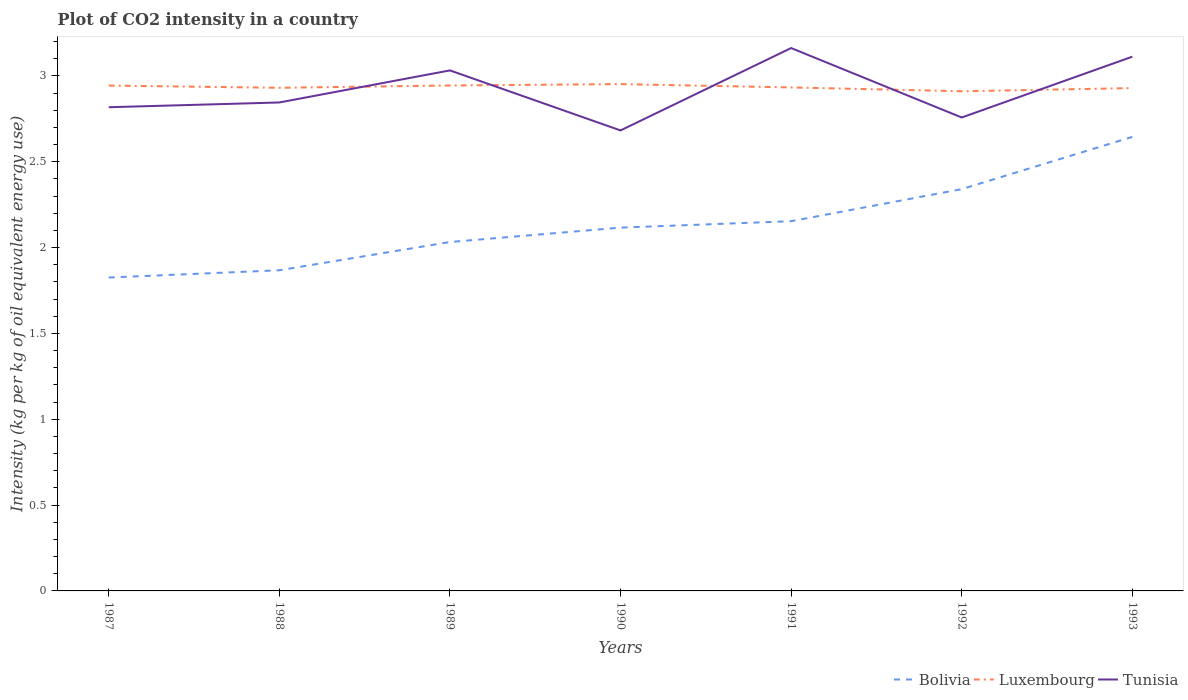Across all years, what is the maximum CO2 intensity in in Bolivia?
Give a very brief answer. 1.83. In which year was the CO2 intensity in in Tunisia maximum?
Keep it short and to the point. 1990. What is the total CO2 intensity in in Tunisia in the graph?
Provide a succinct answer. 0.35. What is the difference between the highest and the second highest CO2 intensity in in Bolivia?
Provide a short and direct response. 0.82. What is the difference between the highest and the lowest CO2 intensity in in Bolivia?
Provide a short and direct response. 3. Is the CO2 intensity in in Tunisia strictly greater than the CO2 intensity in in Luxembourg over the years?
Provide a succinct answer. No. What is the difference between two consecutive major ticks on the Y-axis?
Offer a terse response. 0.5. Are the values on the major ticks of Y-axis written in scientific E-notation?
Provide a succinct answer. No. Does the graph contain any zero values?
Provide a succinct answer. No. What is the title of the graph?
Your response must be concise. Plot of CO2 intensity in a country. Does "Ethiopia" appear as one of the legend labels in the graph?
Keep it short and to the point. No. What is the label or title of the X-axis?
Give a very brief answer. Years. What is the label or title of the Y-axis?
Your answer should be compact. Intensity (kg per kg of oil equivalent energy use). What is the Intensity (kg per kg of oil equivalent energy use) in Bolivia in 1987?
Ensure brevity in your answer.  1.83. What is the Intensity (kg per kg of oil equivalent energy use) of Luxembourg in 1987?
Your answer should be compact. 2.94. What is the Intensity (kg per kg of oil equivalent energy use) of Tunisia in 1987?
Offer a terse response. 2.82. What is the Intensity (kg per kg of oil equivalent energy use) of Bolivia in 1988?
Your answer should be very brief. 1.87. What is the Intensity (kg per kg of oil equivalent energy use) of Luxembourg in 1988?
Offer a very short reply. 2.93. What is the Intensity (kg per kg of oil equivalent energy use) in Tunisia in 1988?
Give a very brief answer. 2.85. What is the Intensity (kg per kg of oil equivalent energy use) of Bolivia in 1989?
Make the answer very short. 2.03. What is the Intensity (kg per kg of oil equivalent energy use) of Luxembourg in 1989?
Provide a succinct answer. 2.94. What is the Intensity (kg per kg of oil equivalent energy use) in Tunisia in 1989?
Your response must be concise. 3.03. What is the Intensity (kg per kg of oil equivalent energy use) in Bolivia in 1990?
Provide a short and direct response. 2.12. What is the Intensity (kg per kg of oil equivalent energy use) of Luxembourg in 1990?
Offer a terse response. 2.95. What is the Intensity (kg per kg of oil equivalent energy use) of Tunisia in 1990?
Provide a succinct answer. 2.68. What is the Intensity (kg per kg of oil equivalent energy use) in Bolivia in 1991?
Make the answer very short. 2.15. What is the Intensity (kg per kg of oil equivalent energy use) of Luxembourg in 1991?
Offer a terse response. 2.93. What is the Intensity (kg per kg of oil equivalent energy use) in Tunisia in 1991?
Your answer should be very brief. 3.16. What is the Intensity (kg per kg of oil equivalent energy use) of Bolivia in 1992?
Keep it short and to the point. 2.34. What is the Intensity (kg per kg of oil equivalent energy use) of Luxembourg in 1992?
Your response must be concise. 2.91. What is the Intensity (kg per kg of oil equivalent energy use) in Tunisia in 1992?
Your answer should be compact. 2.76. What is the Intensity (kg per kg of oil equivalent energy use) of Bolivia in 1993?
Ensure brevity in your answer.  2.64. What is the Intensity (kg per kg of oil equivalent energy use) of Luxembourg in 1993?
Provide a succinct answer. 2.93. What is the Intensity (kg per kg of oil equivalent energy use) in Tunisia in 1993?
Keep it short and to the point. 3.11. Across all years, what is the maximum Intensity (kg per kg of oil equivalent energy use) in Bolivia?
Your response must be concise. 2.64. Across all years, what is the maximum Intensity (kg per kg of oil equivalent energy use) of Luxembourg?
Make the answer very short. 2.95. Across all years, what is the maximum Intensity (kg per kg of oil equivalent energy use) in Tunisia?
Your answer should be compact. 3.16. Across all years, what is the minimum Intensity (kg per kg of oil equivalent energy use) in Bolivia?
Offer a terse response. 1.83. Across all years, what is the minimum Intensity (kg per kg of oil equivalent energy use) in Luxembourg?
Ensure brevity in your answer.  2.91. Across all years, what is the minimum Intensity (kg per kg of oil equivalent energy use) of Tunisia?
Give a very brief answer. 2.68. What is the total Intensity (kg per kg of oil equivalent energy use) of Bolivia in the graph?
Give a very brief answer. 14.98. What is the total Intensity (kg per kg of oil equivalent energy use) of Luxembourg in the graph?
Your answer should be compact. 20.54. What is the total Intensity (kg per kg of oil equivalent energy use) of Tunisia in the graph?
Make the answer very short. 20.41. What is the difference between the Intensity (kg per kg of oil equivalent energy use) in Bolivia in 1987 and that in 1988?
Provide a succinct answer. -0.04. What is the difference between the Intensity (kg per kg of oil equivalent energy use) in Luxembourg in 1987 and that in 1988?
Keep it short and to the point. 0.01. What is the difference between the Intensity (kg per kg of oil equivalent energy use) of Tunisia in 1987 and that in 1988?
Keep it short and to the point. -0.03. What is the difference between the Intensity (kg per kg of oil equivalent energy use) in Bolivia in 1987 and that in 1989?
Offer a terse response. -0.21. What is the difference between the Intensity (kg per kg of oil equivalent energy use) in Luxembourg in 1987 and that in 1989?
Keep it short and to the point. -0. What is the difference between the Intensity (kg per kg of oil equivalent energy use) in Tunisia in 1987 and that in 1989?
Provide a short and direct response. -0.21. What is the difference between the Intensity (kg per kg of oil equivalent energy use) of Bolivia in 1987 and that in 1990?
Make the answer very short. -0.29. What is the difference between the Intensity (kg per kg of oil equivalent energy use) of Luxembourg in 1987 and that in 1990?
Your response must be concise. -0.01. What is the difference between the Intensity (kg per kg of oil equivalent energy use) in Tunisia in 1987 and that in 1990?
Ensure brevity in your answer.  0.14. What is the difference between the Intensity (kg per kg of oil equivalent energy use) of Bolivia in 1987 and that in 1991?
Provide a short and direct response. -0.33. What is the difference between the Intensity (kg per kg of oil equivalent energy use) in Luxembourg in 1987 and that in 1991?
Your answer should be compact. 0.01. What is the difference between the Intensity (kg per kg of oil equivalent energy use) of Tunisia in 1987 and that in 1991?
Your answer should be very brief. -0.34. What is the difference between the Intensity (kg per kg of oil equivalent energy use) of Bolivia in 1987 and that in 1992?
Offer a very short reply. -0.52. What is the difference between the Intensity (kg per kg of oil equivalent energy use) of Luxembourg in 1987 and that in 1992?
Offer a terse response. 0.03. What is the difference between the Intensity (kg per kg of oil equivalent energy use) of Tunisia in 1987 and that in 1992?
Offer a very short reply. 0.06. What is the difference between the Intensity (kg per kg of oil equivalent energy use) in Bolivia in 1987 and that in 1993?
Your answer should be very brief. -0.82. What is the difference between the Intensity (kg per kg of oil equivalent energy use) of Luxembourg in 1987 and that in 1993?
Provide a succinct answer. 0.01. What is the difference between the Intensity (kg per kg of oil equivalent energy use) in Tunisia in 1987 and that in 1993?
Provide a succinct answer. -0.29. What is the difference between the Intensity (kg per kg of oil equivalent energy use) in Bolivia in 1988 and that in 1989?
Keep it short and to the point. -0.16. What is the difference between the Intensity (kg per kg of oil equivalent energy use) of Luxembourg in 1988 and that in 1989?
Keep it short and to the point. -0.01. What is the difference between the Intensity (kg per kg of oil equivalent energy use) of Tunisia in 1988 and that in 1989?
Your answer should be very brief. -0.19. What is the difference between the Intensity (kg per kg of oil equivalent energy use) of Bolivia in 1988 and that in 1990?
Provide a short and direct response. -0.25. What is the difference between the Intensity (kg per kg of oil equivalent energy use) of Luxembourg in 1988 and that in 1990?
Make the answer very short. -0.02. What is the difference between the Intensity (kg per kg of oil equivalent energy use) in Tunisia in 1988 and that in 1990?
Your response must be concise. 0.16. What is the difference between the Intensity (kg per kg of oil equivalent energy use) of Bolivia in 1988 and that in 1991?
Offer a terse response. -0.29. What is the difference between the Intensity (kg per kg of oil equivalent energy use) of Luxembourg in 1988 and that in 1991?
Offer a terse response. -0. What is the difference between the Intensity (kg per kg of oil equivalent energy use) of Tunisia in 1988 and that in 1991?
Offer a terse response. -0.32. What is the difference between the Intensity (kg per kg of oil equivalent energy use) in Bolivia in 1988 and that in 1992?
Make the answer very short. -0.47. What is the difference between the Intensity (kg per kg of oil equivalent energy use) in Luxembourg in 1988 and that in 1992?
Offer a very short reply. 0.02. What is the difference between the Intensity (kg per kg of oil equivalent energy use) in Tunisia in 1988 and that in 1992?
Offer a terse response. 0.09. What is the difference between the Intensity (kg per kg of oil equivalent energy use) of Bolivia in 1988 and that in 1993?
Ensure brevity in your answer.  -0.78. What is the difference between the Intensity (kg per kg of oil equivalent energy use) of Luxembourg in 1988 and that in 1993?
Your response must be concise. 0. What is the difference between the Intensity (kg per kg of oil equivalent energy use) of Tunisia in 1988 and that in 1993?
Make the answer very short. -0.27. What is the difference between the Intensity (kg per kg of oil equivalent energy use) in Bolivia in 1989 and that in 1990?
Your answer should be compact. -0.08. What is the difference between the Intensity (kg per kg of oil equivalent energy use) in Luxembourg in 1989 and that in 1990?
Provide a short and direct response. -0.01. What is the difference between the Intensity (kg per kg of oil equivalent energy use) of Tunisia in 1989 and that in 1990?
Provide a succinct answer. 0.35. What is the difference between the Intensity (kg per kg of oil equivalent energy use) in Bolivia in 1989 and that in 1991?
Your answer should be compact. -0.12. What is the difference between the Intensity (kg per kg of oil equivalent energy use) of Luxembourg in 1989 and that in 1991?
Keep it short and to the point. 0.01. What is the difference between the Intensity (kg per kg of oil equivalent energy use) in Tunisia in 1989 and that in 1991?
Your answer should be very brief. -0.13. What is the difference between the Intensity (kg per kg of oil equivalent energy use) of Bolivia in 1989 and that in 1992?
Your response must be concise. -0.31. What is the difference between the Intensity (kg per kg of oil equivalent energy use) of Luxembourg in 1989 and that in 1992?
Make the answer very short. 0.03. What is the difference between the Intensity (kg per kg of oil equivalent energy use) in Tunisia in 1989 and that in 1992?
Your answer should be very brief. 0.27. What is the difference between the Intensity (kg per kg of oil equivalent energy use) of Bolivia in 1989 and that in 1993?
Your answer should be very brief. -0.61. What is the difference between the Intensity (kg per kg of oil equivalent energy use) of Luxembourg in 1989 and that in 1993?
Offer a very short reply. 0.02. What is the difference between the Intensity (kg per kg of oil equivalent energy use) in Tunisia in 1989 and that in 1993?
Your response must be concise. -0.08. What is the difference between the Intensity (kg per kg of oil equivalent energy use) of Bolivia in 1990 and that in 1991?
Provide a short and direct response. -0.04. What is the difference between the Intensity (kg per kg of oil equivalent energy use) in Luxembourg in 1990 and that in 1991?
Your response must be concise. 0.02. What is the difference between the Intensity (kg per kg of oil equivalent energy use) in Tunisia in 1990 and that in 1991?
Provide a short and direct response. -0.48. What is the difference between the Intensity (kg per kg of oil equivalent energy use) of Bolivia in 1990 and that in 1992?
Your answer should be compact. -0.22. What is the difference between the Intensity (kg per kg of oil equivalent energy use) in Luxembourg in 1990 and that in 1992?
Your response must be concise. 0.04. What is the difference between the Intensity (kg per kg of oil equivalent energy use) in Tunisia in 1990 and that in 1992?
Ensure brevity in your answer.  -0.08. What is the difference between the Intensity (kg per kg of oil equivalent energy use) of Bolivia in 1990 and that in 1993?
Give a very brief answer. -0.53. What is the difference between the Intensity (kg per kg of oil equivalent energy use) in Luxembourg in 1990 and that in 1993?
Keep it short and to the point. 0.02. What is the difference between the Intensity (kg per kg of oil equivalent energy use) of Tunisia in 1990 and that in 1993?
Provide a succinct answer. -0.43. What is the difference between the Intensity (kg per kg of oil equivalent energy use) in Bolivia in 1991 and that in 1992?
Provide a short and direct response. -0.19. What is the difference between the Intensity (kg per kg of oil equivalent energy use) in Luxembourg in 1991 and that in 1992?
Ensure brevity in your answer.  0.02. What is the difference between the Intensity (kg per kg of oil equivalent energy use) in Tunisia in 1991 and that in 1992?
Keep it short and to the point. 0.4. What is the difference between the Intensity (kg per kg of oil equivalent energy use) of Bolivia in 1991 and that in 1993?
Give a very brief answer. -0.49. What is the difference between the Intensity (kg per kg of oil equivalent energy use) in Luxembourg in 1991 and that in 1993?
Ensure brevity in your answer.  0. What is the difference between the Intensity (kg per kg of oil equivalent energy use) in Tunisia in 1991 and that in 1993?
Your answer should be very brief. 0.05. What is the difference between the Intensity (kg per kg of oil equivalent energy use) of Bolivia in 1992 and that in 1993?
Keep it short and to the point. -0.3. What is the difference between the Intensity (kg per kg of oil equivalent energy use) in Luxembourg in 1992 and that in 1993?
Your answer should be compact. -0.02. What is the difference between the Intensity (kg per kg of oil equivalent energy use) in Tunisia in 1992 and that in 1993?
Keep it short and to the point. -0.35. What is the difference between the Intensity (kg per kg of oil equivalent energy use) of Bolivia in 1987 and the Intensity (kg per kg of oil equivalent energy use) of Luxembourg in 1988?
Provide a succinct answer. -1.11. What is the difference between the Intensity (kg per kg of oil equivalent energy use) in Bolivia in 1987 and the Intensity (kg per kg of oil equivalent energy use) in Tunisia in 1988?
Your response must be concise. -1.02. What is the difference between the Intensity (kg per kg of oil equivalent energy use) of Luxembourg in 1987 and the Intensity (kg per kg of oil equivalent energy use) of Tunisia in 1988?
Keep it short and to the point. 0.1. What is the difference between the Intensity (kg per kg of oil equivalent energy use) in Bolivia in 1987 and the Intensity (kg per kg of oil equivalent energy use) in Luxembourg in 1989?
Provide a succinct answer. -1.12. What is the difference between the Intensity (kg per kg of oil equivalent energy use) in Bolivia in 1987 and the Intensity (kg per kg of oil equivalent energy use) in Tunisia in 1989?
Provide a short and direct response. -1.21. What is the difference between the Intensity (kg per kg of oil equivalent energy use) of Luxembourg in 1987 and the Intensity (kg per kg of oil equivalent energy use) of Tunisia in 1989?
Provide a short and direct response. -0.09. What is the difference between the Intensity (kg per kg of oil equivalent energy use) in Bolivia in 1987 and the Intensity (kg per kg of oil equivalent energy use) in Luxembourg in 1990?
Give a very brief answer. -1.13. What is the difference between the Intensity (kg per kg of oil equivalent energy use) in Bolivia in 1987 and the Intensity (kg per kg of oil equivalent energy use) in Tunisia in 1990?
Your answer should be compact. -0.86. What is the difference between the Intensity (kg per kg of oil equivalent energy use) in Luxembourg in 1987 and the Intensity (kg per kg of oil equivalent energy use) in Tunisia in 1990?
Keep it short and to the point. 0.26. What is the difference between the Intensity (kg per kg of oil equivalent energy use) of Bolivia in 1987 and the Intensity (kg per kg of oil equivalent energy use) of Luxembourg in 1991?
Give a very brief answer. -1.11. What is the difference between the Intensity (kg per kg of oil equivalent energy use) in Bolivia in 1987 and the Intensity (kg per kg of oil equivalent energy use) in Tunisia in 1991?
Offer a terse response. -1.34. What is the difference between the Intensity (kg per kg of oil equivalent energy use) in Luxembourg in 1987 and the Intensity (kg per kg of oil equivalent energy use) in Tunisia in 1991?
Ensure brevity in your answer.  -0.22. What is the difference between the Intensity (kg per kg of oil equivalent energy use) of Bolivia in 1987 and the Intensity (kg per kg of oil equivalent energy use) of Luxembourg in 1992?
Offer a very short reply. -1.08. What is the difference between the Intensity (kg per kg of oil equivalent energy use) of Bolivia in 1987 and the Intensity (kg per kg of oil equivalent energy use) of Tunisia in 1992?
Offer a very short reply. -0.93. What is the difference between the Intensity (kg per kg of oil equivalent energy use) of Luxembourg in 1987 and the Intensity (kg per kg of oil equivalent energy use) of Tunisia in 1992?
Keep it short and to the point. 0.19. What is the difference between the Intensity (kg per kg of oil equivalent energy use) in Bolivia in 1987 and the Intensity (kg per kg of oil equivalent energy use) in Luxembourg in 1993?
Your response must be concise. -1.1. What is the difference between the Intensity (kg per kg of oil equivalent energy use) in Bolivia in 1987 and the Intensity (kg per kg of oil equivalent energy use) in Tunisia in 1993?
Your response must be concise. -1.29. What is the difference between the Intensity (kg per kg of oil equivalent energy use) in Luxembourg in 1987 and the Intensity (kg per kg of oil equivalent energy use) in Tunisia in 1993?
Offer a terse response. -0.17. What is the difference between the Intensity (kg per kg of oil equivalent energy use) of Bolivia in 1988 and the Intensity (kg per kg of oil equivalent energy use) of Luxembourg in 1989?
Ensure brevity in your answer.  -1.08. What is the difference between the Intensity (kg per kg of oil equivalent energy use) of Bolivia in 1988 and the Intensity (kg per kg of oil equivalent energy use) of Tunisia in 1989?
Provide a short and direct response. -1.16. What is the difference between the Intensity (kg per kg of oil equivalent energy use) in Luxembourg in 1988 and the Intensity (kg per kg of oil equivalent energy use) in Tunisia in 1989?
Provide a succinct answer. -0.1. What is the difference between the Intensity (kg per kg of oil equivalent energy use) in Bolivia in 1988 and the Intensity (kg per kg of oil equivalent energy use) in Luxembourg in 1990?
Your answer should be compact. -1.08. What is the difference between the Intensity (kg per kg of oil equivalent energy use) in Bolivia in 1988 and the Intensity (kg per kg of oil equivalent energy use) in Tunisia in 1990?
Keep it short and to the point. -0.81. What is the difference between the Intensity (kg per kg of oil equivalent energy use) in Luxembourg in 1988 and the Intensity (kg per kg of oil equivalent energy use) in Tunisia in 1990?
Ensure brevity in your answer.  0.25. What is the difference between the Intensity (kg per kg of oil equivalent energy use) of Bolivia in 1988 and the Intensity (kg per kg of oil equivalent energy use) of Luxembourg in 1991?
Give a very brief answer. -1.06. What is the difference between the Intensity (kg per kg of oil equivalent energy use) of Bolivia in 1988 and the Intensity (kg per kg of oil equivalent energy use) of Tunisia in 1991?
Provide a short and direct response. -1.29. What is the difference between the Intensity (kg per kg of oil equivalent energy use) in Luxembourg in 1988 and the Intensity (kg per kg of oil equivalent energy use) in Tunisia in 1991?
Offer a terse response. -0.23. What is the difference between the Intensity (kg per kg of oil equivalent energy use) of Bolivia in 1988 and the Intensity (kg per kg of oil equivalent energy use) of Luxembourg in 1992?
Ensure brevity in your answer.  -1.04. What is the difference between the Intensity (kg per kg of oil equivalent energy use) of Bolivia in 1988 and the Intensity (kg per kg of oil equivalent energy use) of Tunisia in 1992?
Your response must be concise. -0.89. What is the difference between the Intensity (kg per kg of oil equivalent energy use) in Luxembourg in 1988 and the Intensity (kg per kg of oil equivalent energy use) in Tunisia in 1992?
Offer a terse response. 0.17. What is the difference between the Intensity (kg per kg of oil equivalent energy use) of Bolivia in 1988 and the Intensity (kg per kg of oil equivalent energy use) of Luxembourg in 1993?
Ensure brevity in your answer.  -1.06. What is the difference between the Intensity (kg per kg of oil equivalent energy use) in Bolivia in 1988 and the Intensity (kg per kg of oil equivalent energy use) in Tunisia in 1993?
Give a very brief answer. -1.24. What is the difference between the Intensity (kg per kg of oil equivalent energy use) of Luxembourg in 1988 and the Intensity (kg per kg of oil equivalent energy use) of Tunisia in 1993?
Make the answer very short. -0.18. What is the difference between the Intensity (kg per kg of oil equivalent energy use) in Bolivia in 1989 and the Intensity (kg per kg of oil equivalent energy use) in Luxembourg in 1990?
Offer a very short reply. -0.92. What is the difference between the Intensity (kg per kg of oil equivalent energy use) in Bolivia in 1989 and the Intensity (kg per kg of oil equivalent energy use) in Tunisia in 1990?
Provide a short and direct response. -0.65. What is the difference between the Intensity (kg per kg of oil equivalent energy use) in Luxembourg in 1989 and the Intensity (kg per kg of oil equivalent energy use) in Tunisia in 1990?
Give a very brief answer. 0.26. What is the difference between the Intensity (kg per kg of oil equivalent energy use) in Bolivia in 1989 and the Intensity (kg per kg of oil equivalent energy use) in Luxembourg in 1991?
Your response must be concise. -0.9. What is the difference between the Intensity (kg per kg of oil equivalent energy use) of Bolivia in 1989 and the Intensity (kg per kg of oil equivalent energy use) of Tunisia in 1991?
Keep it short and to the point. -1.13. What is the difference between the Intensity (kg per kg of oil equivalent energy use) of Luxembourg in 1989 and the Intensity (kg per kg of oil equivalent energy use) of Tunisia in 1991?
Offer a terse response. -0.22. What is the difference between the Intensity (kg per kg of oil equivalent energy use) of Bolivia in 1989 and the Intensity (kg per kg of oil equivalent energy use) of Luxembourg in 1992?
Keep it short and to the point. -0.88. What is the difference between the Intensity (kg per kg of oil equivalent energy use) of Bolivia in 1989 and the Intensity (kg per kg of oil equivalent energy use) of Tunisia in 1992?
Your response must be concise. -0.73. What is the difference between the Intensity (kg per kg of oil equivalent energy use) in Luxembourg in 1989 and the Intensity (kg per kg of oil equivalent energy use) in Tunisia in 1992?
Keep it short and to the point. 0.19. What is the difference between the Intensity (kg per kg of oil equivalent energy use) of Bolivia in 1989 and the Intensity (kg per kg of oil equivalent energy use) of Luxembourg in 1993?
Your answer should be compact. -0.9. What is the difference between the Intensity (kg per kg of oil equivalent energy use) of Bolivia in 1989 and the Intensity (kg per kg of oil equivalent energy use) of Tunisia in 1993?
Provide a short and direct response. -1.08. What is the difference between the Intensity (kg per kg of oil equivalent energy use) in Luxembourg in 1989 and the Intensity (kg per kg of oil equivalent energy use) in Tunisia in 1993?
Your answer should be compact. -0.17. What is the difference between the Intensity (kg per kg of oil equivalent energy use) of Bolivia in 1990 and the Intensity (kg per kg of oil equivalent energy use) of Luxembourg in 1991?
Provide a succinct answer. -0.82. What is the difference between the Intensity (kg per kg of oil equivalent energy use) in Bolivia in 1990 and the Intensity (kg per kg of oil equivalent energy use) in Tunisia in 1991?
Your answer should be compact. -1.05. What is the difference between the Intensity (kg per kg of oil equivalent energy use) in Luxembourg in 1990 and the Intensity (kg per kg of oil equivalent energy use) in Tunisia in 1991?
Your answer should be compact. -0.21. What is the difference between the Intensity (kg per kg of oil equivalent energy use) in Bolivia in 1990 and the Intensity (kg per kg of oil equivalent energy use) in Luxembourg in 1992?
Your answer should be very brief. -0.79. What is the difference between the Intensity (kg per kg of oil equivalent energy use) of Bolivia in 1990 and the Intensity (kg per kg of oil equivalent energy use) of Tunisia in 1992?
Your response must be concise. -0.64. What is the difference between the Intensity (kg per kg of oil equivalent energy use) of Luxembourg in 1990 and the Intensity (kg per kg of oil equivalent energy use) of Tunisia in 1992?
Your response must be concise. 0.19. What is the difference between the Intensity (kg per kg of oil equivalent energy use) in Bolivia in 1990 and the Intensity (kg per kg of oil equivalent energy use) in Luxembourg in 1993?
Your response must be concise. -0.81. What is the difference between the Intensity (kg per kg of oil equivalent energy use) of Bolivia in 1990 and the Intensity (kg per kg of oil equivalent energy use) of Tunisia in 1993?
Keep it short and to the point. -1. What is the difference between the Intensity (kg per kg of oil equivalent energy use) of Luxembourg in 1990 and the Intensity (kg per kg of oil equivalent energy use) of Tunisia in 1993?
Provide a short and direct response. -0.16. What is the difference between the Intensity (kg per kg of oil equivalent energy use) in Bolivia in 1991 and the Intensity (kg per kg of oil equivalent energy use) in Luxembourg in 1992?
Ensure brevity in your answer.  -0.76. What is the difference between the Intensity (kg per kg of oil equivalent energy use) in Bolivia in 1991 and the Intensity (kg per kg of oil equivalent energy use) in Tunisia in 1992?
Offer a very short reply. -0.6. What is the difference between the Intensity (kg per kg of oil equivalent energy use) in Luxembourg in 1991 and the Intensity (kg per kg of oil equivalent energy use) in Tunisia in 1992?
Provide a succinct answer. 0.18. What is the difference between the Intensity (kg per kg of oil equivalent energy use) of Bolivia in 1991 and the Intensity (kg per kg of oil equivalent energy use) of Luxembourg in 1993?
Offer a very short reply. -0.78. What is the difference between the Intensity (kg per kg of oil equivalent energy use) in Bolivia in 1991 and the Intensity (kg per kg of oil equivalent energy use) in Tunisia in 1993?
Give a very brief answer. -0.96. What is the difference between the Intensity (kg per kg of oil equivalent energy use) of Luxembourg in 1991 and the Intensity (kg per kg of oil equivalent energy use) of Tunisia in 1993?
Provide a short and direct response. -0.18. What is the difference between the Intensity (kg per kg of oil equivalent energy use) in Bolivia in 1992 and the Intensity (kg per kg of oil equivalent energy use) in Luxembourg in 1993?
Your answer should be very brief. -0.59. What is the difference between the Intensity (kg per kg of oil equivalent energy use) in Bolivia in 1992 and the Intensity (kg per kg of oil equivalent energy use) in Tunisia in 1993?
Your answer should be compact. -0.77. What is the difference between the Intensity (kg per kg of oil equivalent energy use) in Luxembourg in 1992 and the Intensity (kg per kg of oil equivalent energy use) in Tunisia in 1993?
Your response must be concise. -0.2. What is the average Intensity (kg per kg of oil equivalent energy use) of Bolivia per year?
Make the answer very short. 2.14. What is the average Intensity (kg per kg of oil equivalent energy use) in Luxembourg per year?
Your response must be concise. 2.93. What is the average Intensity (kg per kg of oil equivalent energy use) of Tunisia per year?
Your answer should be very brief. 2.92. In the year 1987, what is the difference between the Intensity (kg per kg of oil equivalent energy use) in Bolivia and Intensity (kg per kg of oil equivalent energy use) in Luxembourg?
Offer a very short reply. -1.12. In the year 1987, what is the difference between the Intensity (kg per kg of oil equivalent energy use) in Bolivia and Intensity (kg per kg of oil equivalent energy use) in Tunisia?
Ensure brevity in your answer.  -0.99. In the year 1987, what is the difference between the Intensity (kg per kg of oil equivalent energy use) in Luxembourg and Intensity (kg per kg of oil equivalent energy use) in Tunisia?
Ensure brevity in your answer.  0.13. In the year 1988, what is the difference between the Intensity (kg per kg of oil equivalent energy use) of Bolivia and Intensity (kg per kg of oil equivalent energy use) of Luxembourg?
Offer a terse response. -1.06. In the year 1988, what is the difference between the Intensity (kg per kg of oil equivalent energy use) in Bolivia and Intensity (kg per kg of oil equivalent energy use) in Tunisia?
Provide a succinct answer. -0.98. In the year 1988, what is the difference between the Intensity (kg per kg of oil equivalent energy use) in Luxembourg and Intensity (kg per kg of oil equivalent energy use) in Tunisia?
Your response must be concise. 0.09. In the year 1989, what is the difference between the Intensity (kg per kg of oil equivalent energy use) of Bolivia and Intensity (kg per kg of oil equivalent energy use) of Luxembourg?
Offer a terse response. -0.91. In the year 1989, what is the difference between the Intensity (kg per kg of oil equivalent energy use) in Bolivia and Intensity (kg per kg of oil equivalent energy use) in Tunisia?
Keep it short and to the point. -1. In the year 1989, what is the difference between the Intensity (kg per kg of oil equivalent energy use) in Luxembourg and Intensity (kg per kg of oil equivalent energy use) in Tunisia?
Your answer should be very brief. -0.09. In the year 1990, what is the difference between the Intensity (kg per kg of oil equivalent energy use) of Bolivia and Intensity (kg per kg of oil equivalent energy use) of Luxembourg?
Offer a terse response. -0.84. In the year 1990, what is the difference between the Intensity (kg per kg of oil equivalent energy use) of Bolivia and Intensity (kg per kg of oil equivalent energy use) of Tunisia?
Provide a succinct answer. -0.57. In the year 1990, what is the difference between the Intensity (kg per kg of oil equivalent energy use) of Luxembourg and Intensity (kg per kg of oil equivalent energy use) of Tunisia?
Provide a succinct answer. 0.27. In the year 1991, what is the difference between the Intensity (kg per kg of oil equivalent energy use) in Bolivia and Intensity (kg per kg of oil equivalent energy use) in Luxembourg?
Your answer should be compact. -0.78. In the year 1991, what is the difference between the Intensity (kg per kg of oil equivalent energy use) of Bolivia and Intensity (kg per kg of oil equivalent energy use) of Tunisia?
Your answer should be very brief. -1.01. In the year 1991, what is the difference between the Intensity (kg per kg of oil equivalent energy use) in Luxembourg and Intensity (kg per kg of oil equivalent energy use) in Tunisia?
Give a very brief answer. -0.23. In the year 1992, what is the difference between the Intensity (kg per kg of oil equivalent energy use) of Bolivia and Intensity (kg per kg of oil equivalent energy use) of Luxembourg?
Give a very brief answer. -0.57. In the year 1992, what is the difference between the Intensity (kg per kg of oil equivalent energy use) in Bolivia and Intensity (kg per kg of oil equivalent energy use) in Tunisia?
Make the answer very short. -0.42. In the year 1992, what is the difference between the Intensity (kg per kg of oil equivalent energy use) of Luxembourg and Intensity (kg per kg of oil equivalent energy use) of Tunisia?
Provide a short and direct response. 0.15. In the year 1993, what is the difference between the Intensity (kg per kg of oil equivalent energy use) in Bolivia and Intensity (kg per kg of oil equivalent energy use) in Luxembourg?
Provide a short and direct response. -0.28. In the year 1993, what is the difference between the Intensity (kg per kg of oil equivalent energy use) in Bolivia and Intensity (kg per kg of oil equivalent energy use) in Tunisia?
Provide a succinct answer. -0.47. In the year 1993, what is the difference between the Intensity (kg per kg of oil equivalent energy use) in Luxembourg and Intensity (kg per kg of oil equivalent energy use) in Tunisia?
Keep it short and to the point. -0.18. What is the ratio of the Intensity (kg per kg of oil equivalent energy use) in Bolivia in 1987 to that in 1988?
Keep it short and to the point. 0.98. What is the ratio of the Intensity (kg per kg of oil equivalent energy use) of Luxembourg in 1987 to that in 1988?
Offer a very short reply. 1. What is the ratio of the Intensity (kg per kg of oil equivalent energy use) in Tunisia in 1987 to that in 1988?
Offer a very short reply. 0.99. What is the ratio of the Intensity (kg per kg of oil equivalent energy use) of Bolivia in 1987 to that in 1989?
Give a very brief answer. 0.9. What is the ratio of the Intensity (kg per kg of oil equivalent energy use) in Tunisia in 1987 to that in 1989?
Offer a terse response. 0.93. What is the ratio of the Intensity (kg per kg of oil equivalent energy use) in Bolivia in 1987 to that in 1990?
Provide a succinct answer. 0.86. What is the ratio of the Intensity (kg per kg of oil equivalent energy use) in Luxembourg in 1987 to that in 1990?
Keep it short and to the point. 1. What is the ratio of the Intensity (kg per kg of oil equivalent energy use) in Tunisia in 1987 to that in 1990?
Your answer should be compact. 1.05. What is the ratio of the Intensity (kg per kg of oil equivalent energy use) of Bolivia in 1987 to that in 1991?
Offer a terse response. 0.85. What is the ratio of the Intensity (kg per kg of oil equivalent energy use) of Luxembourg in 1987 to that in 1991?
Your answer should be very brief. 1. What is the ratio of the Intensity (kg per kg of oil equivalent energy use) in Tunisia in 1987 to that in 1991?
Provide a succinct answer. 0.89. What is the ratio of the Intensity (kg per kg of oil equivalent energy use) in Bolivia in 1987 to that in 1992?
Ensure brevity in your answer.  0.78. What is the ratio of the Intensity (kg per kg of oil equivalent energy use) in Luxembourg in 1987 to that in 1992?
Your answer should be compact. 1.01. What is the ratio of the Intensity (kg per kg of oil equivalent energy use) in Tunisia in 1987 to that in 1992?
Your answer should be very brief. 1.02. What is the ratio of the Intensity (kg per kg of oil equivalent energy use) of Bolivia in 1987 to that in 1993?
Ensure brevity in your answer.  0.69. What is the ratio of the Intensity (kg per kg of oil equivalent energy use) of Luxembourg in 1987 to that in 1993?
Your response must be concise. 1.01. What is the ratio of the Intensity (kg per kg of oil equivalent energy use) in Tunisia in 1987 to that in 1993?
Provide a succinct answer. 0.91. What is the ratio of the Intensity (kg per kg of oil equivalent energy use) in Bolivia in 1988 to that in 1989?
Offer a very short reply. 0.92. What is the ratio of the Intensity (kg per kg of oil equivalent energy use) in Tunisia in 1988 to that in 1989?
Offer a terse response. 0.94. What is the ratio of the Intensity (kg per kg of oil equivalent energy use) of Bolivia in 1988 to that in 1990?
Make the answer very short. 0.88. What is the ratio of the Intensity (kg per kg of oil equivalent energy use) in Tunisia in 1988 to that in 1990?
Offer a very short reply. 1.06. What is the ratio of the Intensity (kg per kg of oil equivalent energy use) in Bolivia in 1988 to that in 1991?
Offer a terse response. 0.87. What is the ratio of the Intensity (kg per kg of oil equivalent energy use) of Tunisia in 1988 to that in 1991?
Give a very brief answer. 0.9. What is the ratio of the Intensity (kg per kg of oil equivalent energy use) of Bolivia in 1988 to that in 1992?
Provide a succinct answer. 0.8. What is the ratio of the Intensity (kg per kg of oil equivalent energy use) in Luxembourg in 1988 to that in 1992?
Offer a very short reply. 1.01. What is the ratio of the Intensity (kg per kg of oil equivalent energy use) of Tunisia in 1988 to that in 1992?
Keep it short and to the point. 1.03. What is the ratio of the Intensity (kg per kg of oil equivalent energy use) of Bolivia in 1988 to that in 1993?
Your answer should be compact. 0.71. What is the ratio of the Intensity (kg per kg of oil equivalent energy use) in Luxembourg in 1988 to that in 1993?
Your answer should be compact. 1. What is the ratio of the Intensity (kg per kg of oil equivalent energy use) in Tunisia in 1988 to that in 1993?
Keep it short and to the point. 0.91. What is the ratio of the Intensity (kg per kg of oil equivalent energy use) in Bolivia in 1989 to that in 1990?
Ensure brevity in your answer.  0.96. What is the ratio of the Intensity (kg per kg of oil equivalent energy use) in Luxembourg in 1989 to that in 1990?
Make the answer very short. 1. What is the ratio of the Intensity (kg per kg of oil equivalent energy use) in Tunisia in 1989 to that in 1990?
Provide a succinct answer. 1.13. What is the ratio of the Intensity (kg per kg of oil equivalent energy use) in Bolivia in 1989 to that in 1991?
Keep it short and to the point. 0.94. What is the ratio of the Intensity (kg per kg of oil equivalent energy use) of Luxembourg in 1989 to that in 1991?
Provide a succinct answer. 1. What is the ratio of the Intensity (kg per kg of oil equivalent energy use) of Tunisia in 1989 to that in 1991?
Give a very brief answer. 0.96. What is the ratio of the Intensity (kg per kg of oil equivalent energy use) of Bolivia in 1989 to that in 1992?
Provide a succinct answer. 0.87. What is the ratio of the Intensity (kg per kg of oil equivalent energy use) of Luxembourg in 1989 to that in 1992?
Your response must be concise. 1.01. What is the ratio of the Intensity (kg per kg of oil equivalent energy use) in Tunisia in 1989 to that in 1992?
Offer a terse response. 1.1. What is the ratio of the Intensity (kg per kg of oil equivalent energy use) of Bolivia in 1989 to that in 1993?
Offer a very short reply. 0.77. What is the ratio of the Intensity (kg per kg of oil equivalent energy use) of Luxembourg in 1989 to that in 1993?
Ensure brevity in your answer.  1.01. What is the ratio of the Intensity (kg per kg of oil equivalent energy use) of Tunisia in 1989 to that in 1993?
Offer a terse response. 0.97. What is the ratio of the Intensity (kg per kg of oil equivalent energy use) of Bolivia in 1990 to that in 1991?
Keep it short and to the point. 0.98. What is the ratio of the Intensity (kg per kg of oil equivalent energy use) in Luxembourg in 1990 to that in 1991?
Give a very brief answer. 1.01. What is the ratio of the Intensity (kg per kg of oil equivalent energy use) in Tunisia in 1990 to that in 1991?
Make the answer very short. 0.85. What is the ratio of the Intensity (kg per kg of oil equivalent energy use) of Bolivia in 1990 to that in 1992?
Make the answer very short. 0.9. What is the ratio of the Intensity (kg per kg of oil equivalent energy use) of Luxembourg in 1990 to that in 1992?
Make the answer very short. 1.01. What is the ratio of the Intensity (kg per kg of oil equivalent energy use) in Tunisia in 1990 to that in 1992?
Provide a succinct answer. 0.97. What is the ratio of the Intensity (kg per kg of oil equivalent energy use) of Bolivia in 1990 to that in 1993?
Keep it short and to the point. 0.8. What is the ratio of the Intensity (kg per kg of oil equivalent energy use) of Luxembourg in 1990 to that in 1993?
Your answer should be very brief. 1.01. What is the ratio of the Intensity (kg per kg of oil equivalent energy use) of Tunisia in 1990 to that in 1993?
Your answer should be very brief. 0.86. What is the ratio of the Intensity (kg per kg of oil equivalent energy use) in Bolivia in 1991 to that in 1992?
Make the answer very short. 0.92. What is the ratio of the Intensity (kg per kg of oil equivalent energy use) of Luxembourg in 1991 to that in 1992?
Ensure brevity in your answer.  1.01. What is the ratio of the Intensity (kg per kg of oil equivalent energy use) of Tunisia in 1991 to that in 1992?
Your response must be concise. 1.15. What is the ratio of the Intensity (kg per kg of oil equivalent energy use) in Bolivia in 1991 to that in 1993?
Offer a terse response. 0.81. What is the ratio of the Intensity (kg per kg of oil equivalent energy use) of Tunisia in 1991 to that in 1993?
Keep it short and to the point. 1.02. What is the ratio of the Intensity (kg per kg of oil equivalent energy use) in Bolivia in 1992 to that in 1993?
Provide a short and direct response. 0.89. What is the ratio of the Intensity (kg per kg of oil equivalent energy use) in Luxembourg in 1992 to that in 1993?
Provide a succinct answer. 0.99. What is the ratio of the Intensity (kg per kg of oil equivalent energy use) of Tunisia in 1992 to that in 1993?
Offer a very short reply. 0.89. What is the difference between the highest and the second highest Intensity (kg per kg of oil equivalent energy use) in Bolivia?
Your response must be concise. 0.3. What is the difference between the highest and the second highest Intensity (kg per kg of oil equivalent energy use) of Luxembourg?
Provide a short and direct response. 0.01. What is the difference between the highest and the second highest Intensity (kg per kg of oil equivalent energy use) of Tunisia?
Provide a short and direct response. 0.05. What is the difference between the highest and the lowest Intensity (kg per kg of oil equivalent energy use) in Bolivia?
Provide a short and direct response. 0.82. What is the difference between the highest and the lowest Intensity (kg per kg of oil equivalent energy use) in Luxembourg?
Make the answer very short. 0.04. What is the difference between the highest and the lowest Intensity (kg per kg of oil equivalent energy use) of Tunisia?
Keep it short and to the point. 0.48. 